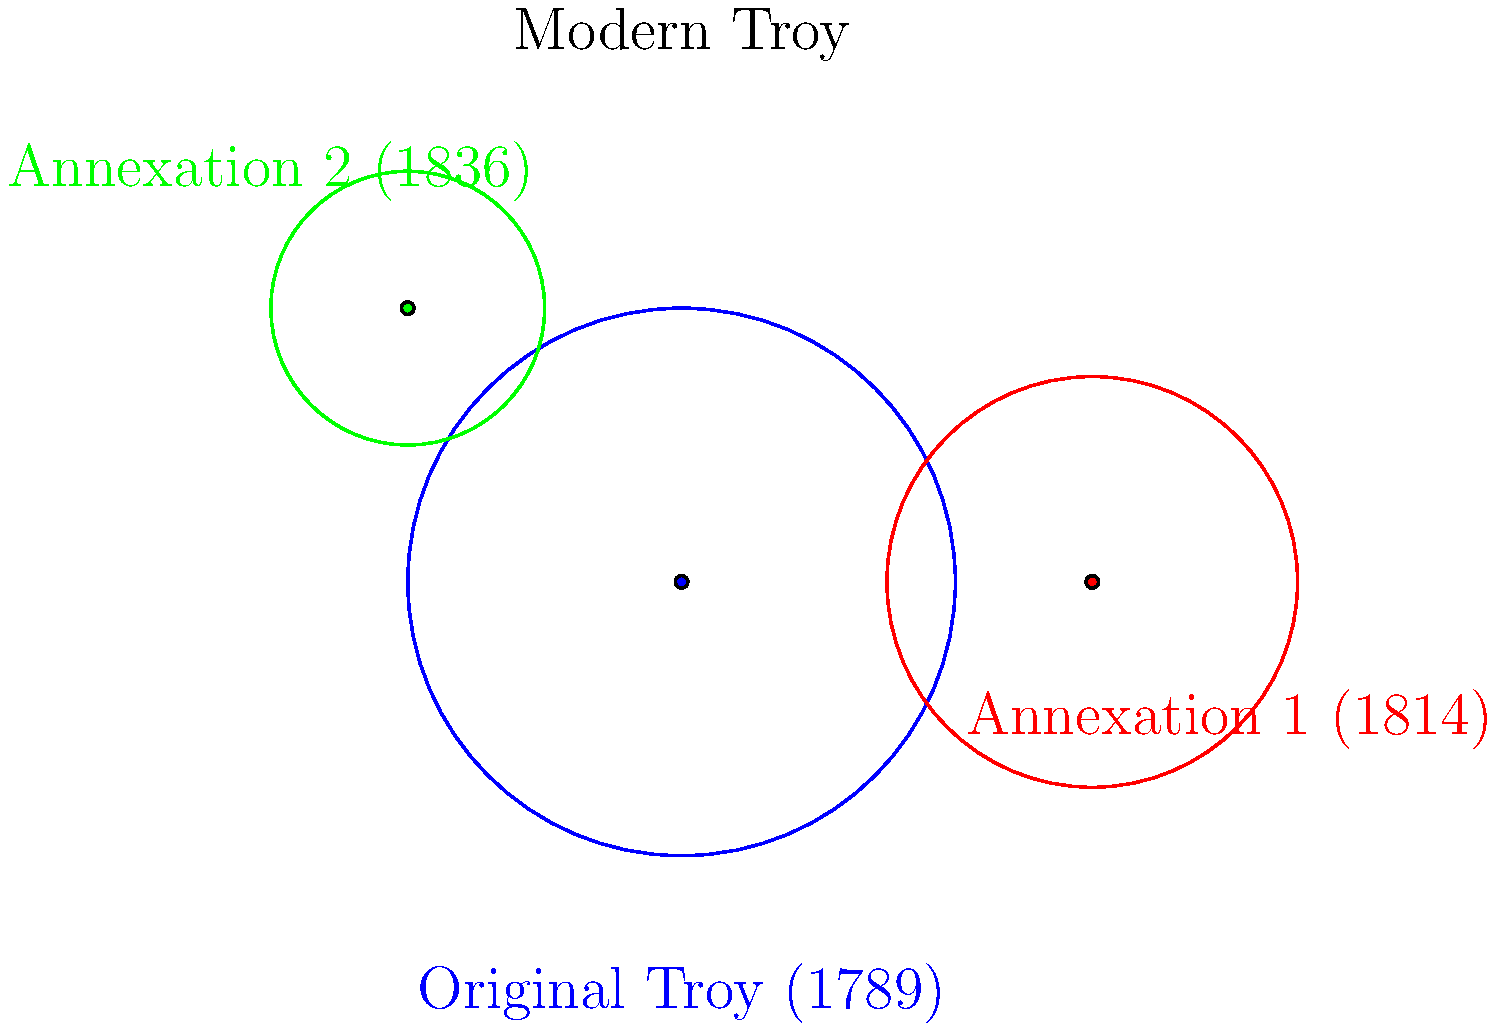Based on the map showing Troy's expansion over time, which annexation significantly extended the city's boundaries to the east, and in what year did this occur? To answer this question, we need to analyze the map and the information provided:

1. The map shows three main areas:
   - Original Troy (1789) in blue
   - Annexation 1 (1814) in red
   - Annexation 2 (1836) in green

2. We need to identify which annexation extended the city's boundaries to the east.

3. Looking at the map:
   - The original Troy (blue circle) is centered at the origin.
   - Annexation 1 (red circle) is clearly to the right (east) of the original Troy.
   - Annexation 2 (green circle) is to the upper left (northwest) of the original Troy.

4. Therefore, Annexation 1 is the one that significantly extended Troy's boundaries to the east.

5. The year associated with Annexation 1 is 1814.
Answer: Annexation 1 in 1814 